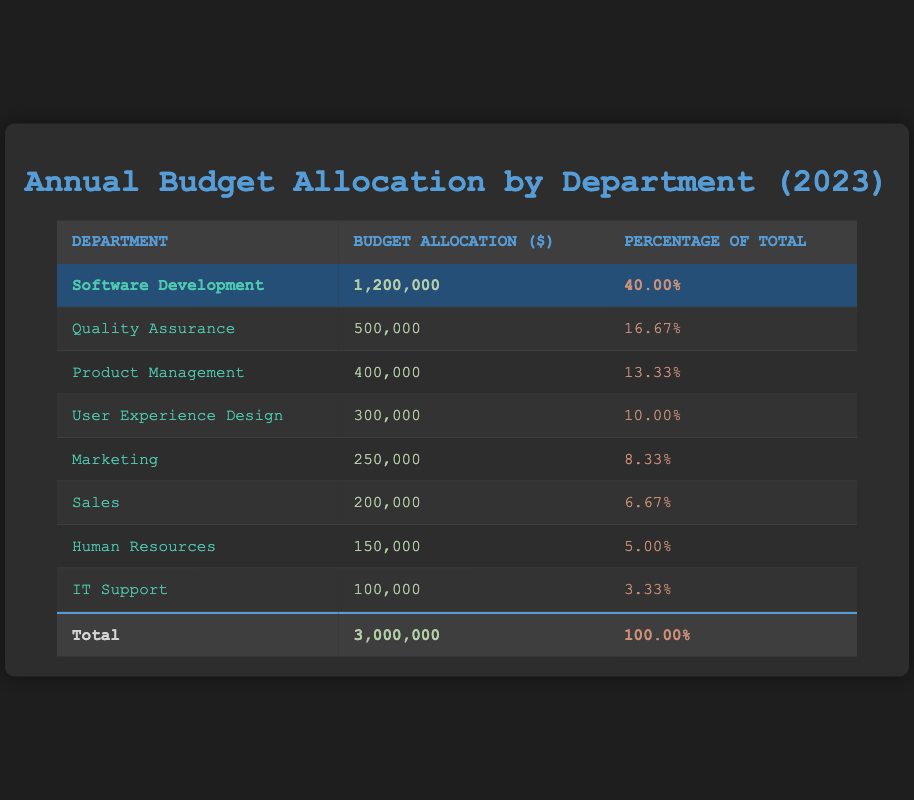What is the total budget allocation for all departments? The total budget allocation is provided at the bottom of the table, summarizing the figures for all departments. It states that the total budget is 3,000,000.
Answer: 3,000,000 What percentage of the total budget is allocated to Software Development? The percentage of the total budget for Software Development is specifically mentioned in the table as 40.00%.
Answer: 40.00% Which department received the second-highest budget allocation? By comparing the budget allocations listed in the table, Quality Assurance has the second-highest budget allocation of 500,000 after Software Development.
Answer: Quality Assurance How much budget is allocated to Human Resources and IT Support combined? To find the combined budget, sum the allocations of Human Resources (150,000) and IT Support (100,000). Thus, 150,000 + 100,000 = 250,000.
Answer: 250,000 Is the budget allocation for Marketing higher than that for User Experience Design? By directly comparing the two allocations, Marketing (250,000) is higher than User Experience Design (300,000). Therefore, the statement is false.
Answer: No What is the average budget allocation across all departments? The total budget is 3,000,000, and there are 8 departments. The average is calculated as 3,000,000 / 8 = 375,000.
Answer: 375,000 Which department accounts for exactly 8.33% of the total budget? Looking at the percentage column in the table, Marketing is the department with an allocation of 250,000, which is exactly 8.33% of the total budget.
Answer: Marketing What is the budget difference between the department with the highest and the lowest allocation? The department with the highest allocation is Software Development (1,200,000) and the lowest is IT Support (100,000). The difference is 1,200,000 - 100,000 = 1,100,000.
Answer: 1,100,000 If you add the budgets of Quality Assurance and Product Management, what will the total be? The budget for Quality Assurance is 500,000 and for Product Management is 400,000. The sum is 500,000 + 400,000 = 900,000.
Answer: 900,000 Is the combined budget of Sales and Human Resources greater than the budget of User Experience Design? Sales has a budget of 200,000 and Human Resources has 150,000, totaling 350,000. User Experience Design has a budget of 300,000. Since 350,000 is greater than 300,000, the answer is yes.
Answer: Yes 